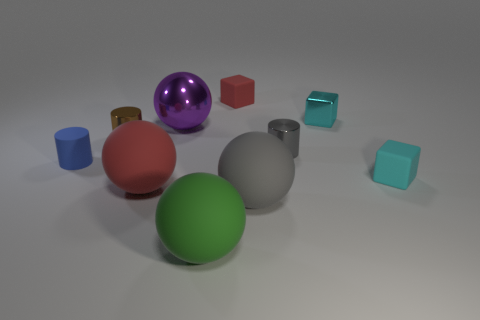How many spheres are large rubber things or small rubber things?
Your response must be concise. 3. There is a sphere that is both left of the gray matte thing and in front of the large red rubber object; what is its size?
Your response must be concise. Large. What number of other objects are there of the same color as the large metallic thing?
Keep it short and to the point. 0. Does the blue cylinder have the same material as the large sphere that is behind the small blue matte cylinder?
Offer a very short reply. No. How many objects are big green matte objects that are on the left side of the gray metal thing or cyan things?
Your answer should be very brief. 3. There is a tiny object that is both left of the cyan shiny block and behind the small brown metal thing; what is its shape?
Your response must be concise. Cube. Is there anything else that is the same size as the metal cube?
Keep it short and to the point. Yes. There is a green thing that is made of the same material as the large gray sphere; what size is it?
Make the answer very short. Large. What number of things are either tiny cyan things that are behind the small matte cylinder or tiny cyan blocks behind the purple object?
Give a very brief answer. 1. Does the red object that is to the left of the purple metallic object have the same size as the tiny gray thing?
Your answer should be very brief. No. 